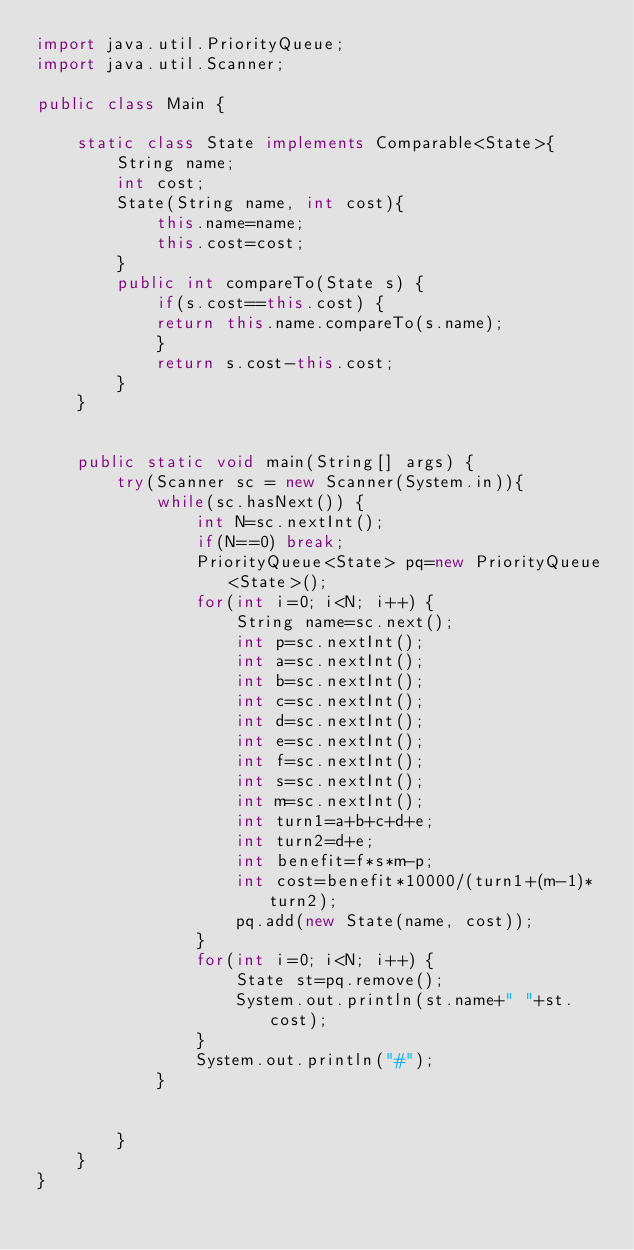Convert code to text. <code><loc_0><loc_0><loc_500><loc_500><_Java_>import java.util.PriorityQueue;
import java.util.Scanner;

public class Main {
    
    static class State implements Comparable<State>{
        String name;
        int cost;
        State(String name, int cost){
            this.name=name;
            this.cost=cost;
        }
        public int compareTo(State s) {
            if(s.cost==this.cost) {
            return this.name.compareTo(s.name);
            }
            return s.cost-this.cost;
        }
    }
    
    
    public static void main(String[] args) {
        try(Scanner sc = new Scanner(System.in)){
            while(sc.hasNext()) {
                int N=sc.nextInt();
                if(N==0) break;
                PriorityQueue<State> pq=new PriorityQueue<State>();
                for(int i=0; i<N; i++) {
                    String name=sc.next();
                    int p=sc.nextInt();
                    int a=sc.nextInt();
                    int b=sc.nextInt();
                    int c=sc.nextInt();
                    int d=sc.nextInt();
                    int e=sc.nextInt();
                    int f=sc.nextInt();
                    int s=sc.nextInt();
                    int m=sc.nextInt();
                    int turn1=a+b+c+d+e;
                    int turn2=d+e;
                    int benefit=f*s*m-p;
                    int cost=benefit*10000/(turn1+(m-1)*turn2);
                    pq.add(new State(name, cost));
                }
                for(int i=0; i<N; i++) {
                    State st=pq.remove();
                    System.out.println(st.name+" "+st.cost);
                }
                System.out.println("#");
            }


        }
    }
} 
</code> 